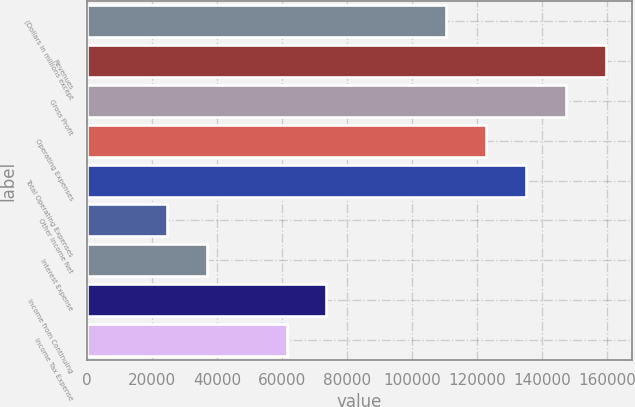Convert chart. <chart><loc_0><loc_0><loc_500><loc_500><bar_chart><fcel>(Dollars in millions except<fcel>Revenues<fcel>Gross Profit<fcel>Operating Expenses<fcel>Total Operating Expenses<fcel>Other Income Net<fcel>Interest Expense<fcel>Income from Continuing<fcel>Income Tax Expense<nl><fcel>110461<fcel>159553<fcel>147280<fcel>122734<fcel>135007<fcel>24551.3<fcel>36824.1<fcel>73642.6<fcel>61369.8<nl></chart> 